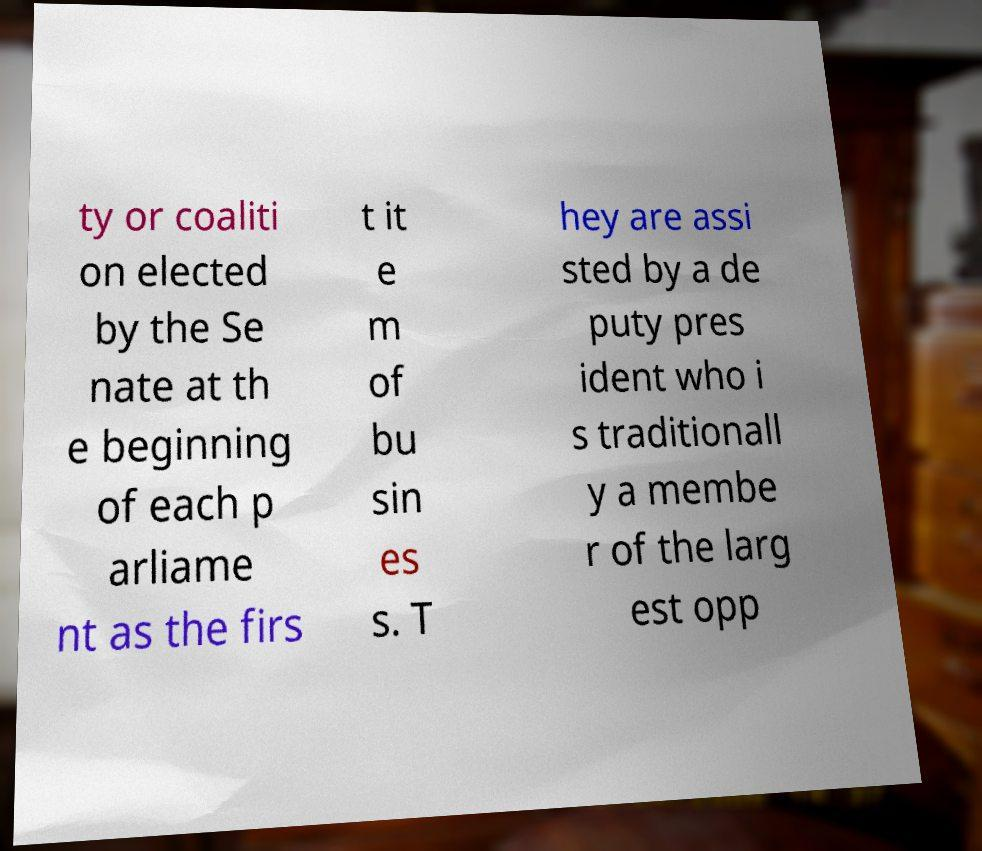What messages or text are displayed in this image? I need them in a readable, typed format. ty or coaliti on elected by the Se nate at th e beginning of each p arliame nt as the firs t it e m of bu sin es s. T hey are assi sted by a de puty pres ident who i s traditionall y a membe r of the larg est opp 